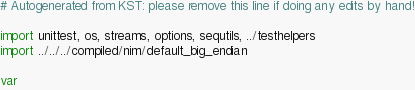<code> <loc_0><loc_0><loc_500><loc_500><_Nim_># Autogenerated from KST: please remove this line if doing any edits by hand!

import unittest, os, streams, options, sequtils, ../testhelpers
import ../../../compiled/nim/default_big_endian

var</code> 